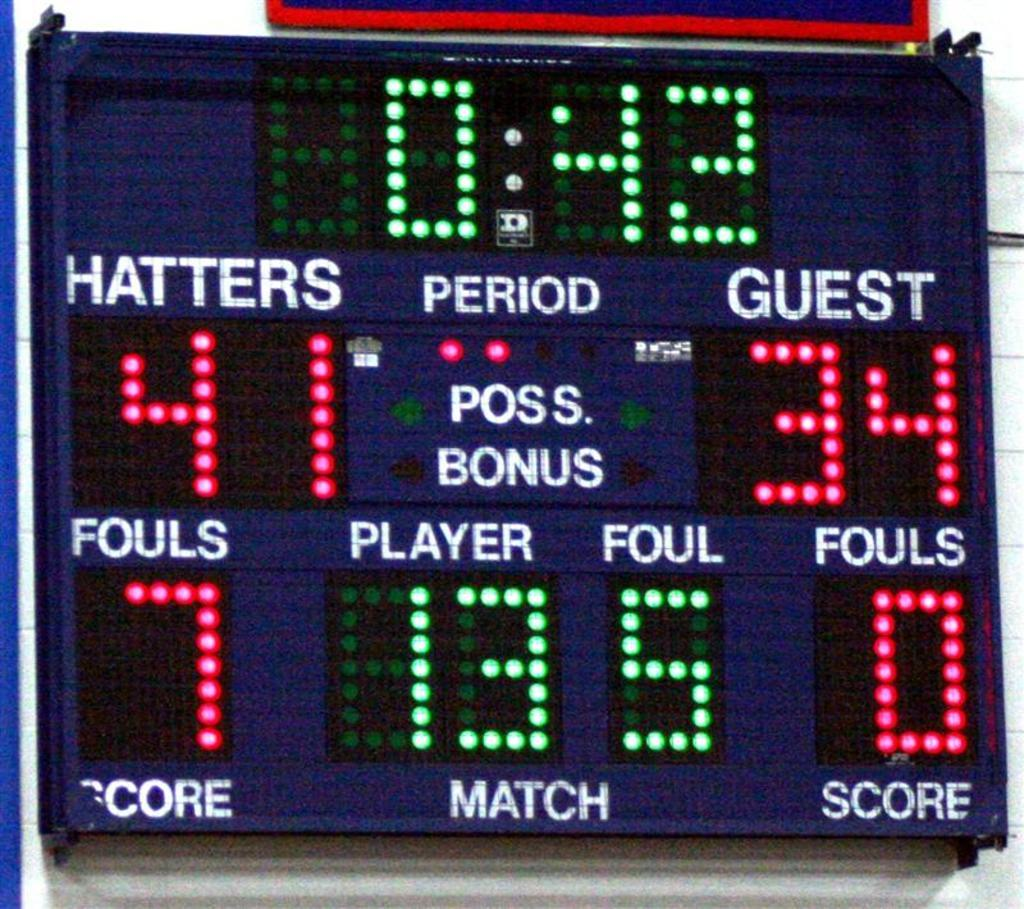<image>
Render a clear and concise summary of the photo. A scoreboard that says 42 seconds left and score 41 to 34 